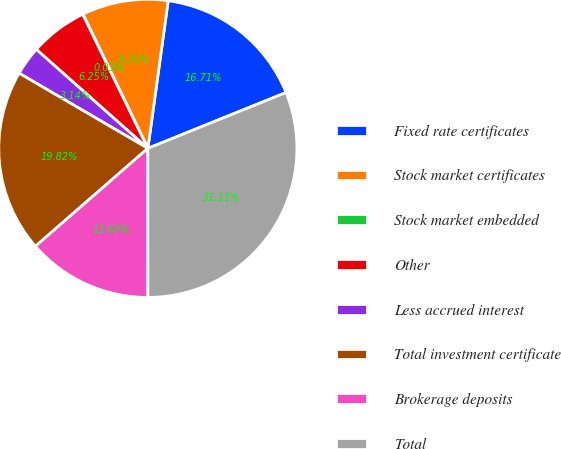Convert chart. <chart><loc_0><loc_0><loc_500><loc_500><pie_chart><fcel>Fixed rate certificates<fcel>Stock market certificates<fcel>Stock market embedded<fcel>Other<fcel>Less accrued interest<fcel>Total investment certificate<fcel>Brokerage deposits<fcel>Total<nl><fcel>16.71%<fcel>9.35%<fcel>0.03%<fcel>6.25%<fcel>3.14%<fcel>19.82%<fcel>13.6%<fcel>31.11%<nl></chart> 